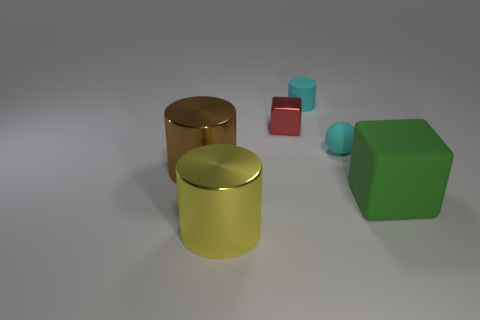Does the tiny matte sphere have the same color as the small rubber cylinder?
Ensure brevity in your answer.  Yes. There is a object that is the same color as the small matte ball; what shape is it?
Your answer should be compact. Cylinder. There is a matte object that is behind the matte ball; what size is it?
Provide a short and direct response. Small. Are there any small objects of the same color as the matte ball?
Make the answer very short. Yes. Does the green object have the same shape as the small object to the left of the tiny rubber cylinder?
Provide a succinct answer. Yes. How many large objects are on the right side of the cyan ball and to the left of the green matte thing?
Give a very brief answer. 0. There is a big object to the right of the small cyan thing that is behind the metallic thing behind the brown metal cylinder; what shape is it?
Your answer should be very brief. Cube. How many balls are either metallic objects or big matte things?
Provide a succinct answer. 0. Does the tiny rubber object behind the red block have the same color as the rubber cube?
Offer a terse response. No. The brown object to the left of the metallic thing behind the tiny object that is right of the matte cylinder is made of what material?
Offer a very short reply. Metal. 